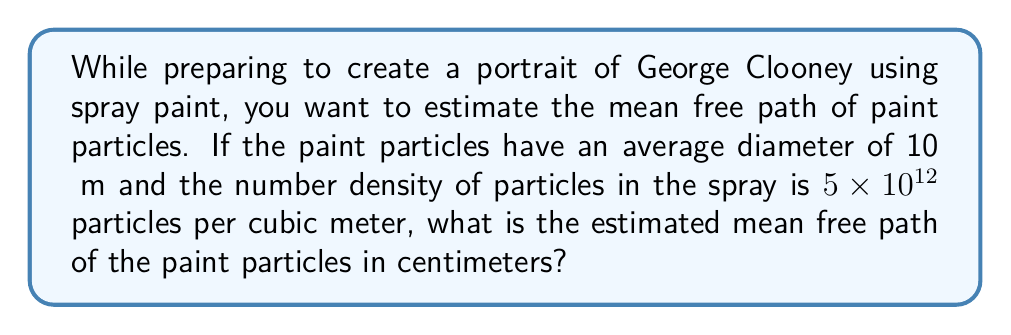Give your solution to this math problem. To estimate the mean free path of paint particles, we'll use the formula for mean free path in a gas-like system:

$$ \lambda = \frac{1}{\sqrt{2} \pi d^2 n} $$

Where:
$\lambda$ = mean free path
$d$ = diameter of particles
$n$ = number density of particles

Step 1: Convert the particle diameter to meters
$d = 10 \text{ μm} = 10 \times 10^{-6} \text{ m}$

Step 2: Use the given number density
$n = 5 \times 10^{12} \text{ particles/m}^3$

Step 3: Substitute values into the formula
$$ \lambda = \frac{1}{\sqrt{2} \pi (10 \times 10^{-6} \text{ m})^2 (5 \times 10^{12} \text{ m}^{-3})} $$

Step 4: Calculate
$$ \lambda = \frac{1}{\sqrt{2} \pi (10^{-10}) (5 \times 10^{12})} $$
$$ \lambda = \frac{1}{2.22 \times 10^3} \text{ m} $$
$$ \lambda \approx 4.5 \times 10^{-4} \text{ m} $$

Step 5: Convert to centimeters
$$ \lambda \approx 4.5 \times 10^{-2} \text{ cm} $$
Answer: $4.5 \times 10^{-2} \text{ cm}$ 